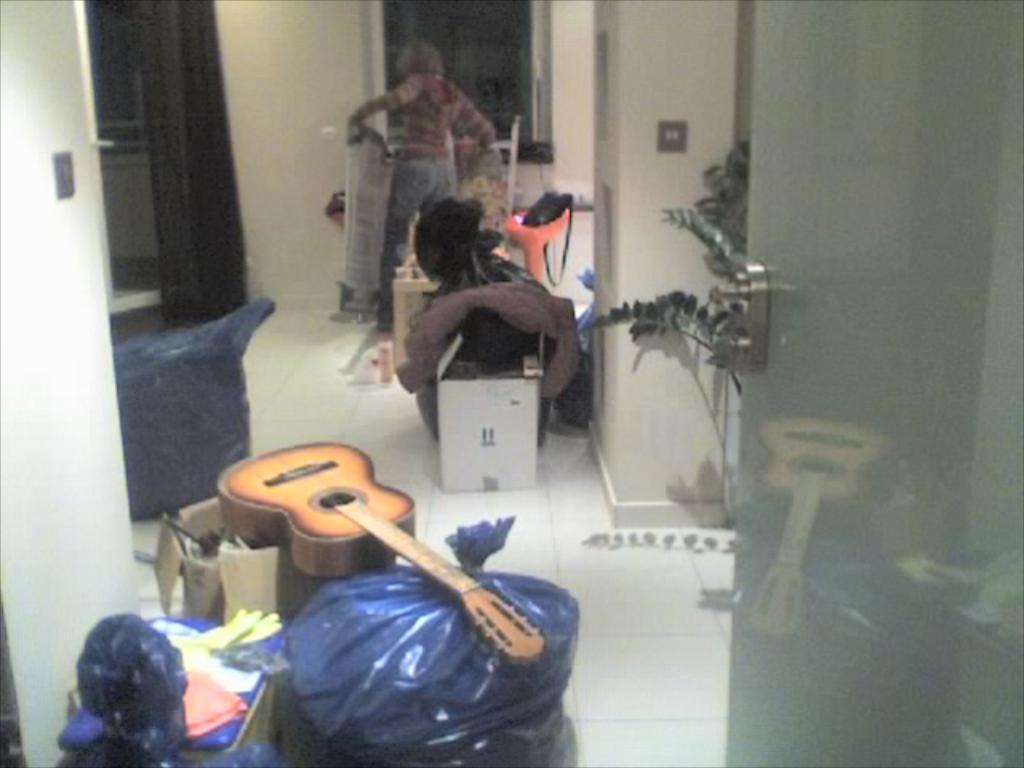In one or two sentences, can you explain what this image depicts? In this picture we can see guitar placed on a cardboard box and here we have some plastic covers and in background we can see man standing and some more items, wall, curtains, floor, tree, switch board. 